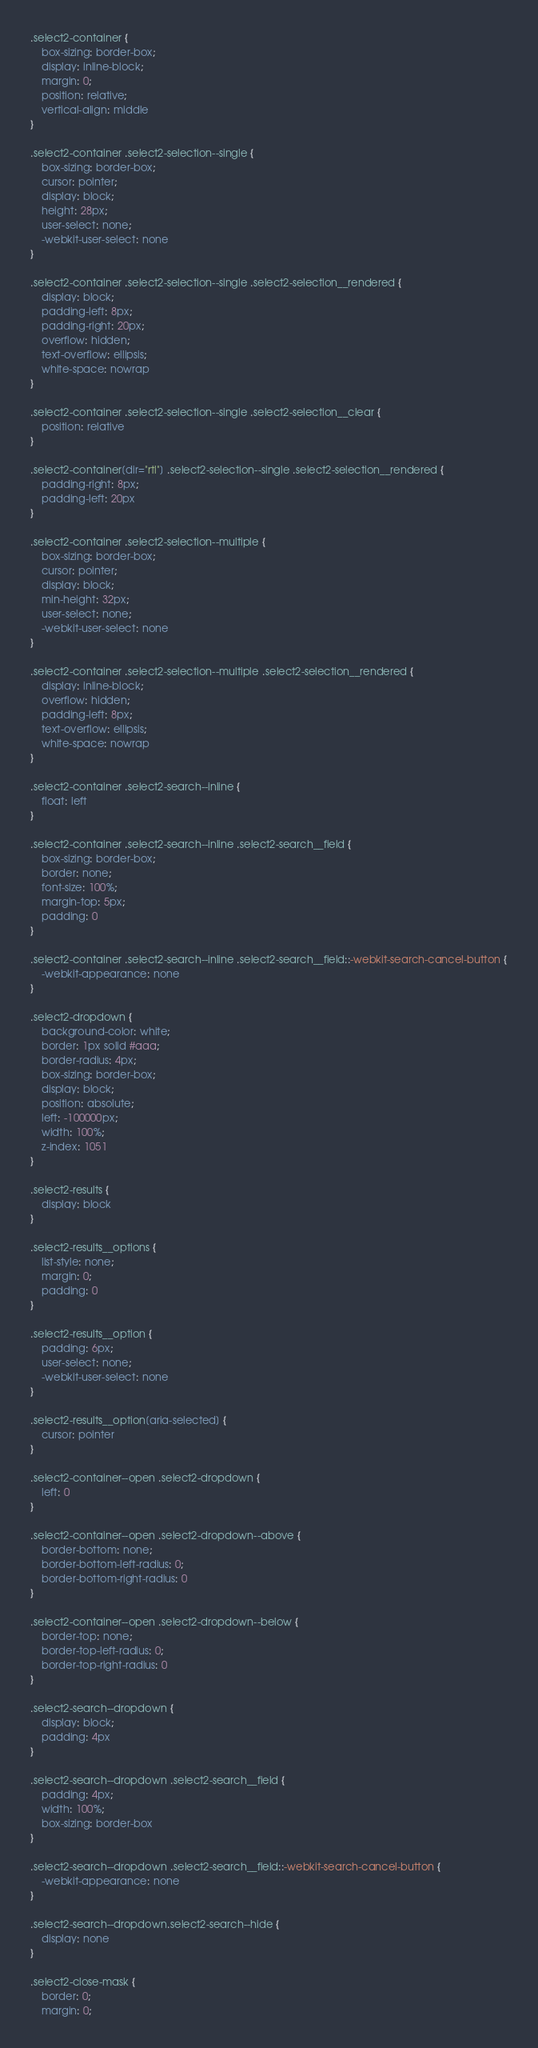<code> <loc_0><loc_0><loc_500><loc_500><_CSS_>.select2-container {
	box-sizing: border-box;
	display: inline-block;
	margin: 0;
	position: relative;
	vertical-align: middle
}

.select2-container .select2-selection--single {
	box-sizing: border-box;
	cursor: pointer;
	display: block;
	height: 28px;
	user-select: none;
	-webkit-user-select: none
}

.select2-container .select2-selection--single .select2-selection__rendered {
	display: block;
	padding-left: 8px;
	padding-right: 20px;
	overflow: hidden;
	text-overflow: ellipsis;
	white-space: nowrap
}

.select2-container .select2-selection--single .select2-selection__clear {
	position: relative
}

.select2-container[dir="rtl"] .select2-selection--single .select2-selection__rendered {
	padding-right: 8px;
	padding-left: 20px
}

.select2-container .select2-selection--multiple {
	box-sizing: border-box;
	cursor: pointer;
	display: block;
	min-height: 32px;
	user-select: none;
	-webkit-user-select: none
}

.select2-container .select2-selection--multiple .select2-selection__rendered {
	display: inline-block;
	overflow: hidden;
	padding-left: 8px;
	text-overflow: ellipsis;
	white-space: nowrap
}

.select2-container .select2-search--inline {
	float: left
}

.select2-container .select2-search--inline .select2-search__field {
	box-sizing: border-box;
	border: none;
	font-size: 100%;
	margin-top: 5px;
	padding: 0
}

.select2-container .select2-search--inline .select2-search__field::-webkit-search-cancel-button {
	-webkit-appearance: none
}

.select2-dropdown {
	background-color: white;
	border: 1px solid #aaa;
	border-radius: 4px;
	box-sizing: border-box;
	display: block;
	position: absolute;
	left: -100000px;
	width: 100%;
	z-index: 1051
}

.select2-results {
	display: block
}

.select2-results__options {
	list-style: none;
	margin: 0;
	padding: 0
}

.select2-results__option {
	padding: 6px;
	user-select: none;
	-webkit-user-select: none
}

.select2-results__option[aria-selected] {
	cursor: pointer
}

.select2-container--open .select2-dropdown {
	left: 0
}

.select2-container--open .select2-dropdown--above {
	border-bottom: none;
	border-bottom-left-radius: 0;
	border-bottom-right-radius: 0
}

.select2-container--open .select2-dropdown--below {
	border-top: none;
	border-top-left-radius: 0;
	border-top-right-radius: 0
}

.select2-search--dropdown {
	display: block;
	padding: 4px
}

.select2-search--dropdown .select2-search__field {
	padding: 4px;
	width: 100%;
	box-sizing: border-box
}

.select2-search--dropdown .select2-search__field::-webkit-search-cancel-button {
	-webkit-appearance: none
}

.select2-search--dropdown.select2-search--hide {
	display: none
}

.select2-close-mask {
	border: 0;
	margin: 0;</code> 